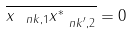Convert formula to latex. <formula><loc_0><loc_0><loc_500><loc_500>\overline { x _ { { \ n k } , 1 } x ^ { * } _ { { \ n k } ^ { \prime } , 2 } } = 0</formula> 